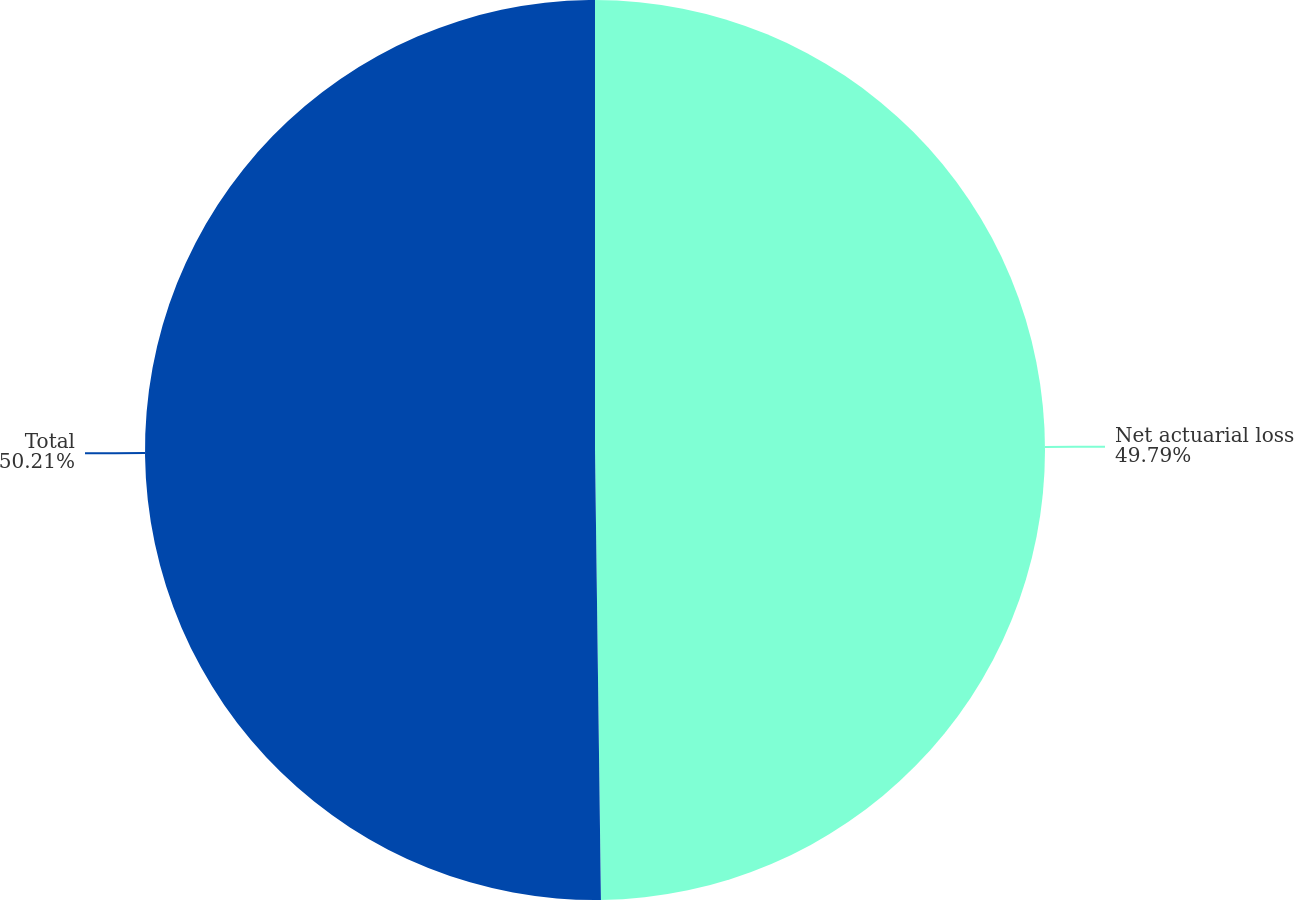Convert chart. <chart><loc_0><loc_0><loc_500><loc_500><pie_chart><fcel>Net actuarial loss<fcel>Total<nl><fcel>49.79%<fcel>50.21%<nl></chart> 